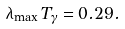Convert formula to latex. <formula><loc_0><loc_0><loc_500><loc_500>\lambda _ { \max } T _ { \gamma } = 0 . 2 9 .</formula> 